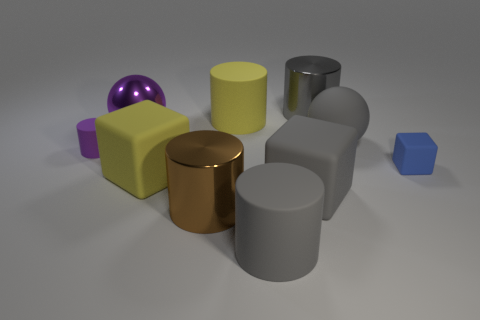Subtract all yellow cylinders. How many cylinders are left? 4 Subtract all gray matte cylinders. How many cylinders are left? 4 Subtract all brown cylinders. Subtract all blue cubes. How many cylinders are left? 4 Subtract all cubes. How many objects are left? 7 Subtract 0 blue spheres. How many objects are left? 10 Subtract all small cylinders. Subtract all small blue blocks. How many objects are left? 8 Add 9 big yellow cylinders. How many big yellow cylinders are left? 10 Add 1 tiny gray rubber spheres. How many tiny gray rubber spheres exist? 1 